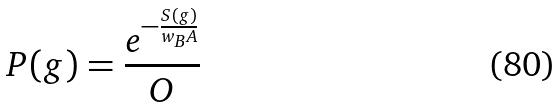<formula> <loc_0><loc_0><loc_500><loc_500>P ( g ) = \frac { e ^ { - \frac { S ( g ) } { w _ { B } A } } } { O }</formula> 